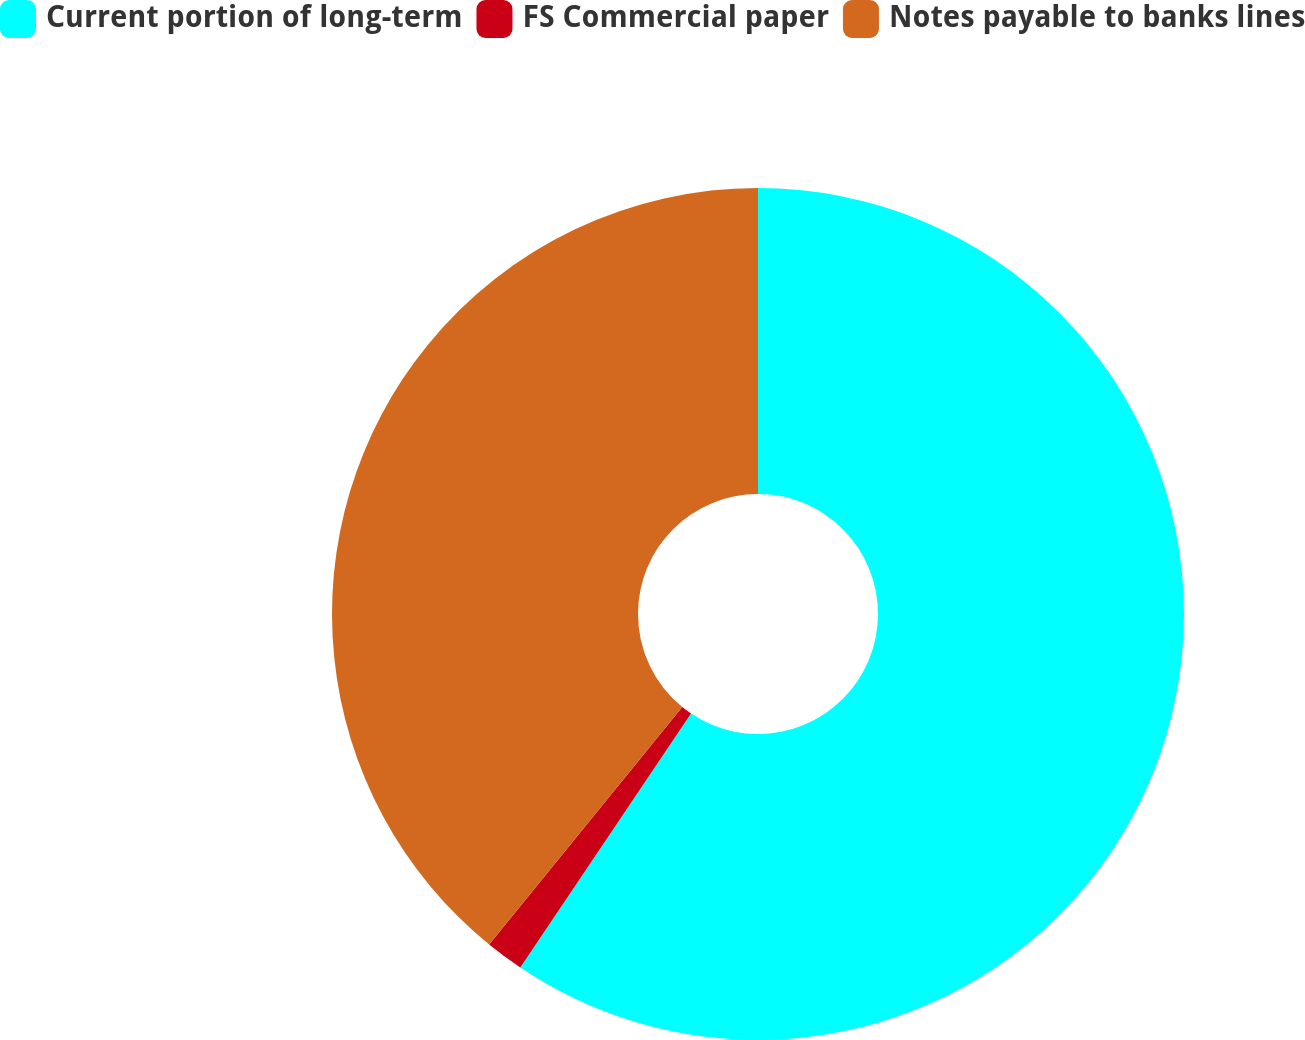Convert chart to OTSL. <chart><loc_0><loc_0><loc_500><loc_500><pie_chart><fcel>Current portion of long-term<fcel>FS Commercial paper<fcel>Notes payable to banks lines<nl><fcel>59.42%<fcel>1.45%<fcel>39.13%<nl></chart> 